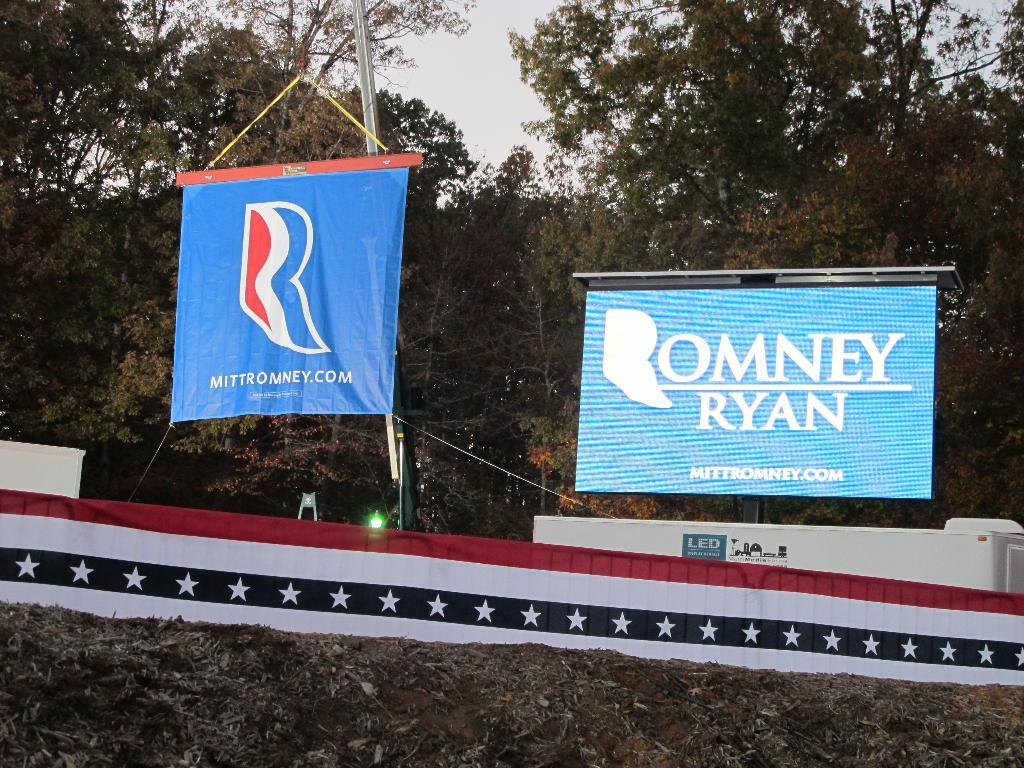<image>
Relay a brief, clear account of the picture shown. Two advertisements for the Romney Ryan politcal campaign sitting above a building. 